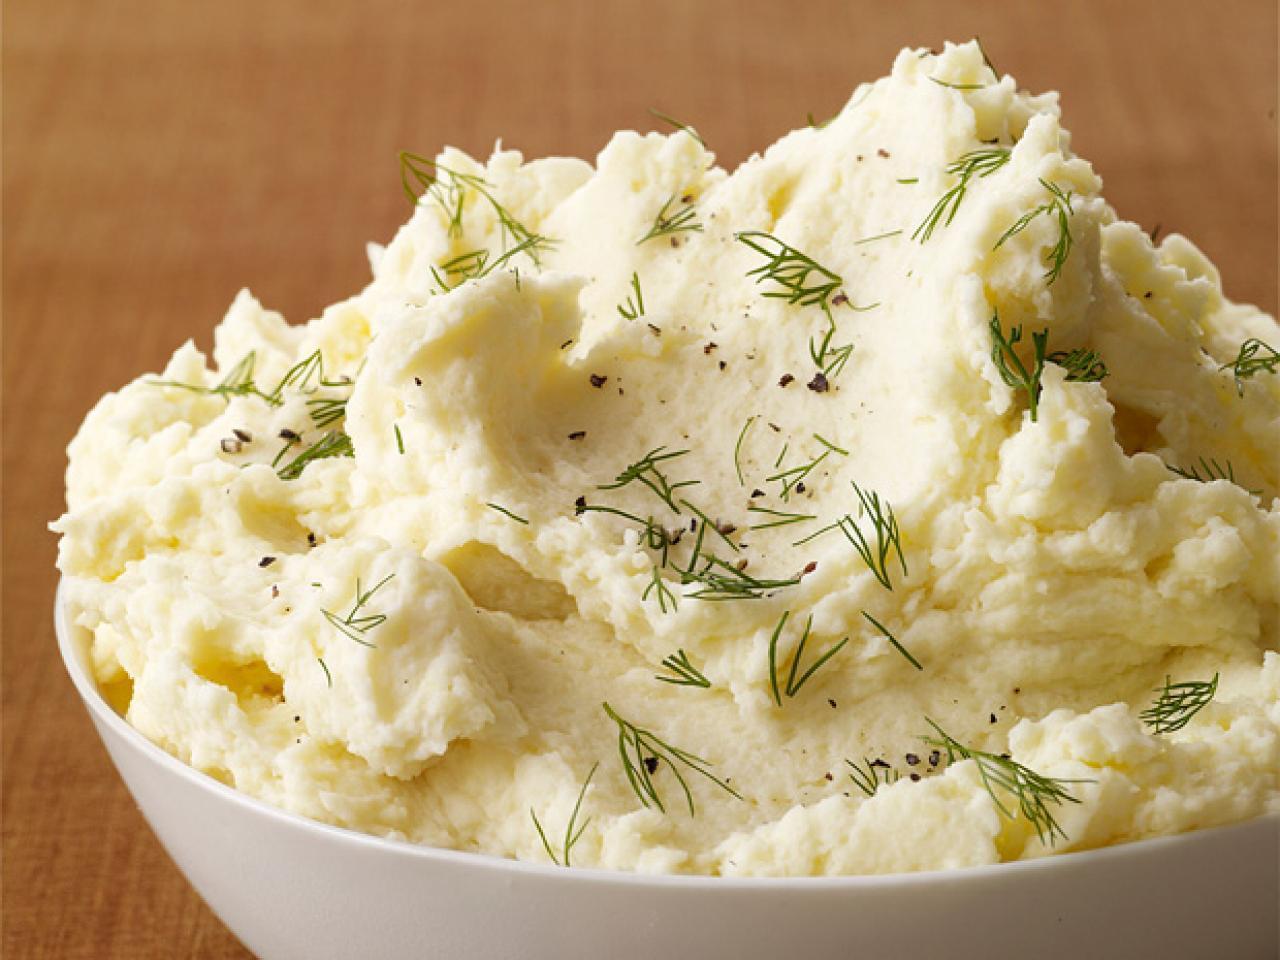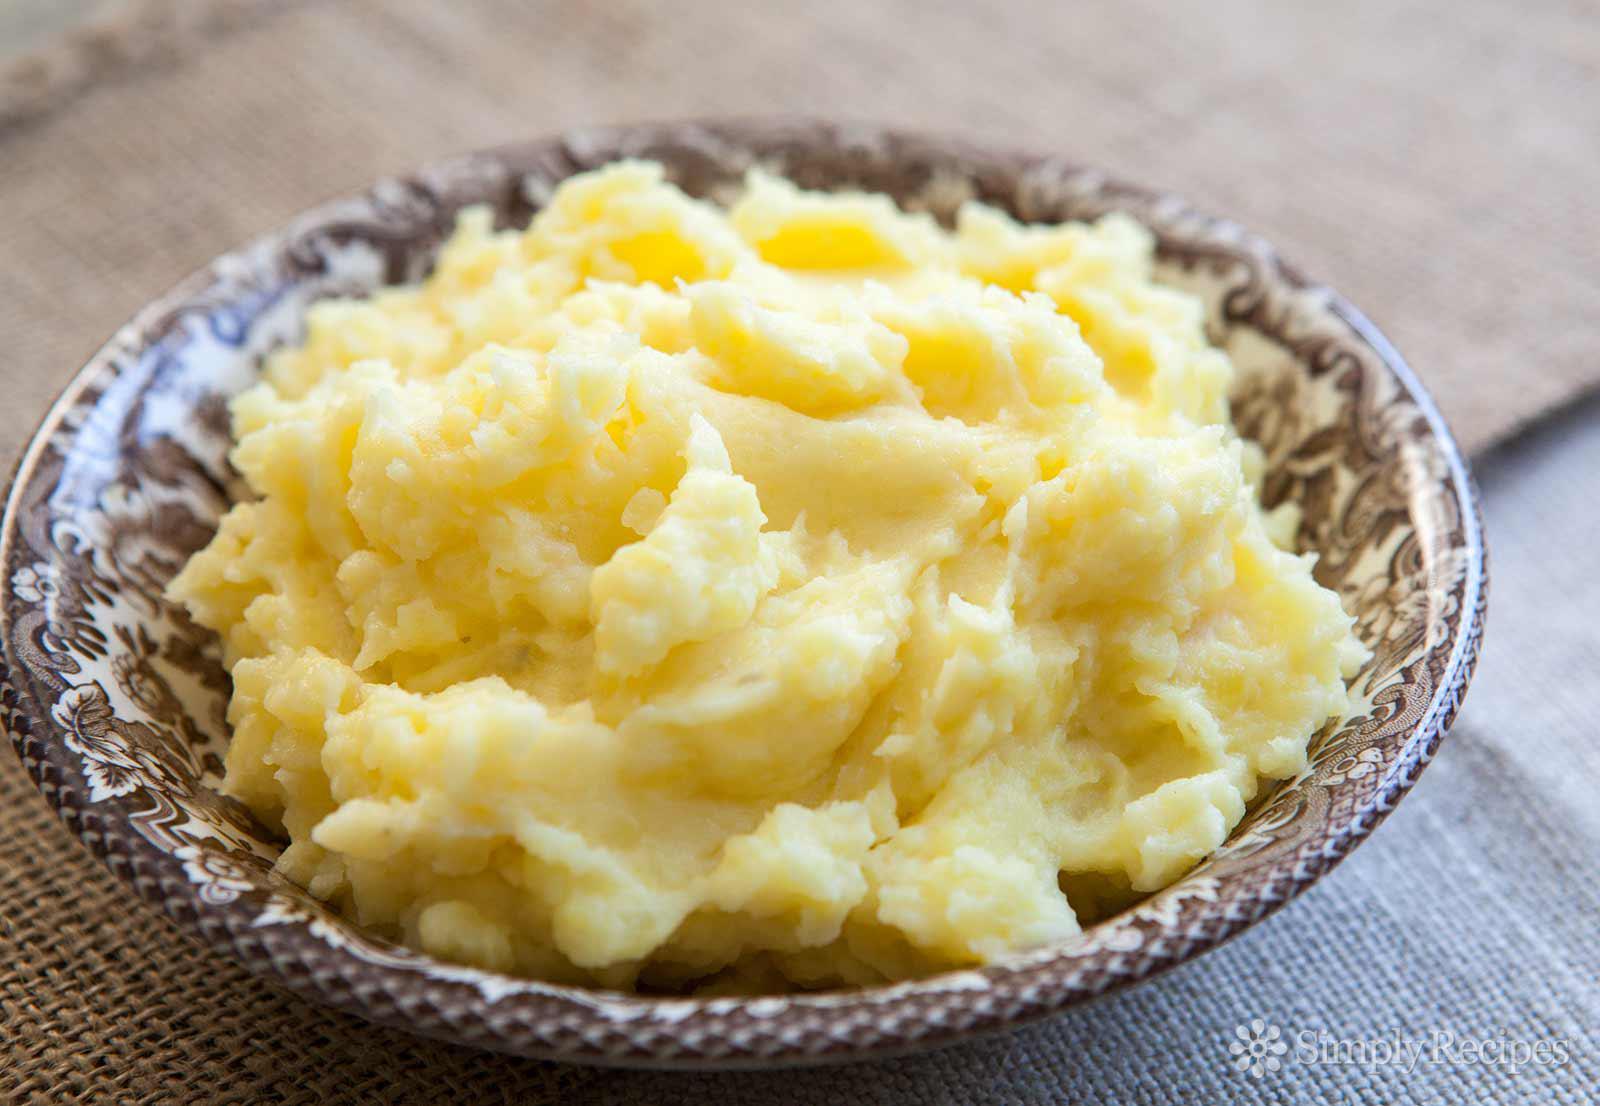The first image is the image on the left, the second image is the image on the right. Evaluate the accuracy of this statement regarding the images: "There is a bowl of mashed potatoes with a spoon in it". Is it true? Answer yes or no. No. The first image is the image on the left, the second image is the image on the right. For the images displayed, is the sentence "No bowl of potatoes has a utensil handle sticking out of it." factually correct? Answer yes or no. Yes. 